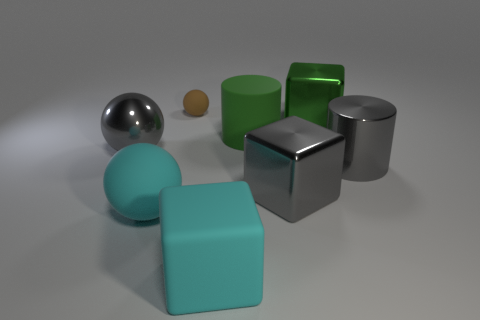Subtract all metallic balls. How many balls are left? 2 Add 2 brown matte things. How many objects exist? 10 Subtract 1 cylinders. How many cylinders are left? 1 Subtract all cyan balls. How many balls are left? 2 Subtract all cubes. How many objects are left? 5 Subtract all tiny rubber cylinders. Subtract all brown matte balls. How many objects are left? 7 Add 4 big green rubber things. How many big green rubber things are left? 5 Add 3 metallic things. How many metallic things exist? 7 Subtract 1 cyan cubes. How many objects are left? 7 Subtract all green blocks. Subtract all green cylinders. How many blocks are left? 2 